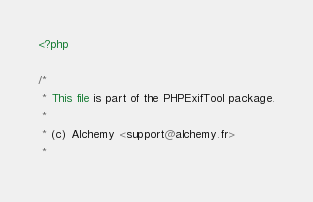Convert code to text. <code><loc_0><loc_0><loc_500><loc_500><_PHP_><?php

/*
 * This file is part of the PHPExifTool package.
 *
 * (c) Alchemy <support@alchemy.fr>
 *</code> 